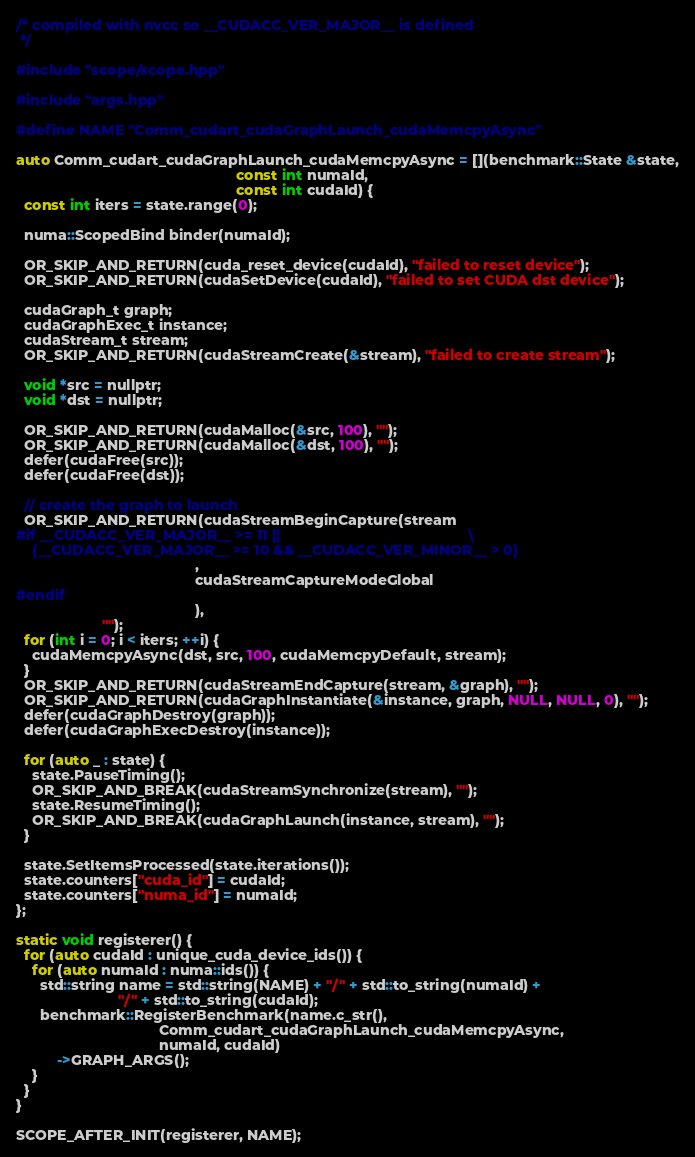<code> <loc_0><loc_0><loc_500><loc_500><_Cuda_>/* compiled with nvcc so __CUDACC_VER_MAJOR__ is defined
 */

#include "scope/scope.hpp"

#include "args.hpp"

#define NAME "Comm_cudart_cudaGraphLaunch_cudaMemcpyAsync"

auto Comm_cudart_cudaGraphLaunch_cudaMemcpyAsync = [](benchmark::State &state,
                                                      const int numaId,
                                                      const int cudaId) {
  const int iters = state.range(0);

  numa::ScopedBind binder(numaId);

  OR_SKIP_AND_RETURN(cuda_reset_device(cudaId), "failed to reset device");
  OR_SKIP_AND_RETURN(cudaSetDevice(cudaId), "failed to set CUDA dst device");

  cudaGraph_t graph;
  cudaGraphExec_t instance;
  cudaStream_t stream;
  OR_SKIP_AND_RETURN(cudaStreamCreate(&stream), "failed to create stream");

  void *src = nullptr;
  void *dst = nullptr;

  OR_SKIP_AND_RETURN(cudaMalloc(&src, 100), "");
  OR_SKIP_AND_RETURN(cudaMalloc(&dst, 100), "");
  defer(cudaFree(src));
  defer(cudaFree(dst));

  // create the graph to launch
  OR_SKIP_AND_RETURN(cudaStreamBeginCapture(stream
#if __CUDACC_VER_MAJOR__ >= 11 ||                                              \
    (__CUDACC_VER_MAJOR__ >= 10 && __CUDACC_VER_MINOR__ > 0)
                                            ,
                                            cudaStreamCaptureModeGlobal
#endif
                                            ),
                     "");
  for (int i = 0; i < iters; ++i) {
    cudaMemcpyAsync(dst, src, 100, cudaMemcpyDefault, stream);
  }
  OR_SKIP_AND_RETURN(cudaStreamEndCapture(stream, &graph), "");
  OR_SKIP_AND_RETURN(cudaGraphInstantiate(&instance, graph, NULL, NULL, 0), "");
  defer(cudaGraphDestroy(graph));
  defer(cudaGraphExecDestroy(instance));

  for (auto _ : state) {
    state.PauseTiming();
    OR_SKIP_AND_BREAK(cudaStreamSynchronize(stream), "");
    state.ResumeTiming();
    OR_SKIP_AND_BREAK(cudaGraphLaunch(instance, stream), "");
  }

  state.SetItemsProcessed(state.iterations());
  state.counters["cuda_id"] = cudaId;
  state.counters["numa_id"] = numaId;
};

static void registerer() {
  for (auto cudaId : unique_cuda_device_ids()) {
    for (auto numaId : numa::ids()) {
      std::string name = std::string(NAME) + "/" + std::to_string(numaId) +
                         "/" + std::to_string(cudaId);
      benchmark::RegisterBenchmark(name.c_str(),
                                   Comm_cudart_cudaGraphLaunch_cudaMemcpyAsync,
                                   numaId, cudaId)
          ->GRAPH_ARGS();
    }
  }
}

SCOPE_AFTER_INIT(registerer, NAME);
</code> 